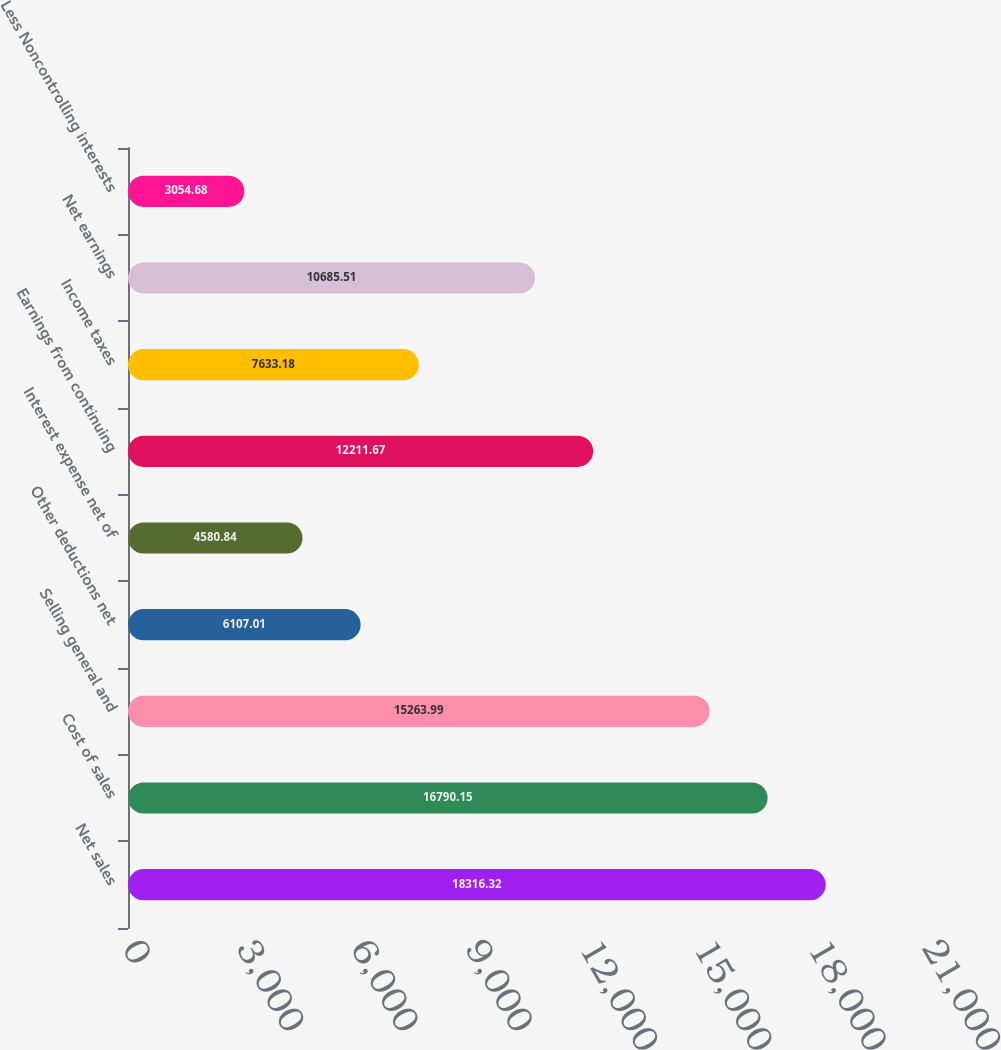<chart> <loc_0><loc_0><loc_500><loc_500><bar_chart><fcel>Net sales<fcel>Cost of sales<fcel>Selling general and<fcel>Other deductions net<fcel>Interest expense net of<fcel>Earnings from continuing<fcel>Income taxes<fcel>Net earnings<fcel>Less Noncontrolling interests<nl><fcel>18316.3<fcel>16790.2<fcel>15264<fcel>6107.01<fcel>4580.84<fcel>12211.7<fcel>7633.18<fcel>10685.5<fcel>3054.68<nl></chart> 